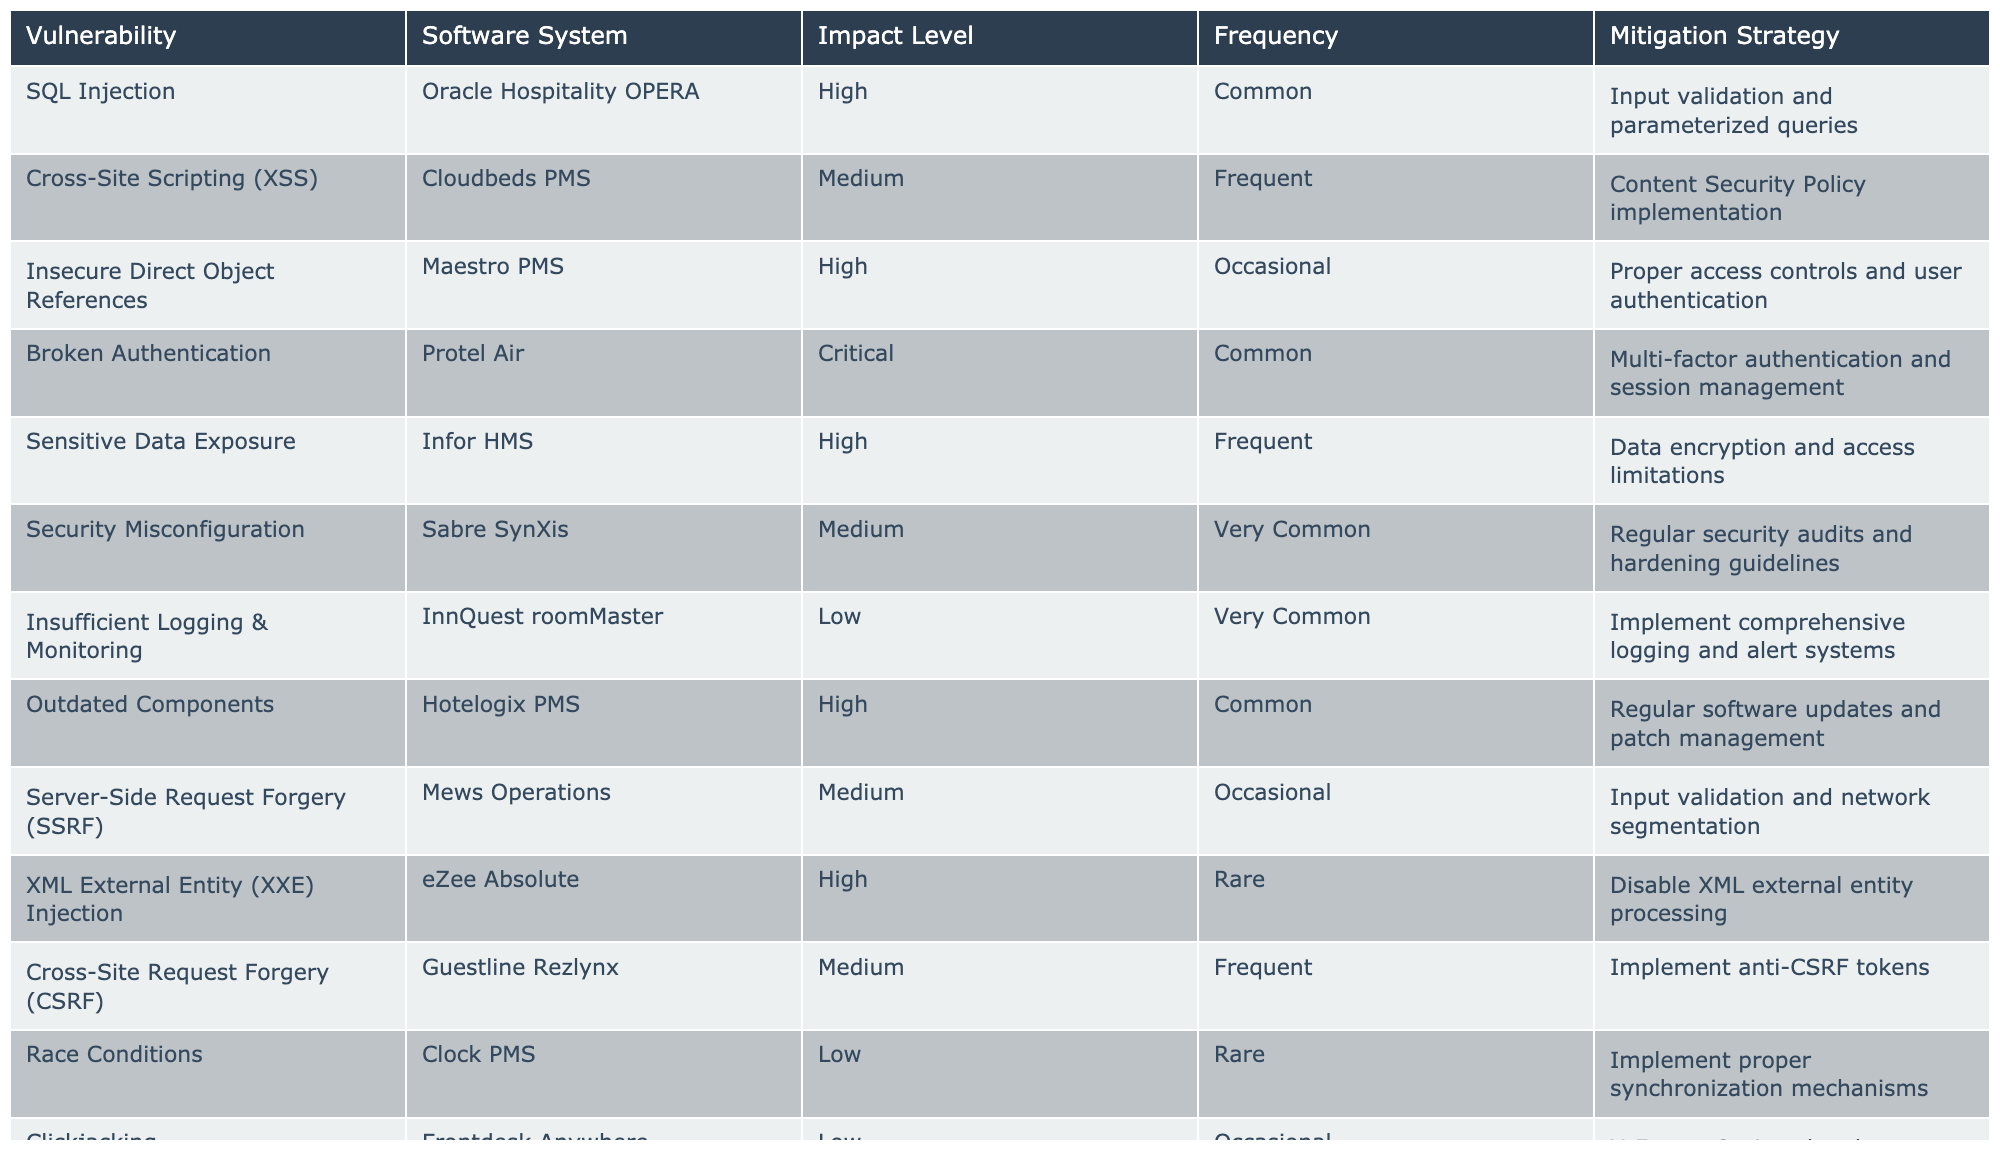What is the highest impact vulnerability listed in the table? The table shows several vulnerabilities along with their corresponding impact levels. By inspecting the impact levels, "Broken Authentication" has a "Critical" level, which is the highest.
Answer: Broken Authentication Which software system is associated with SQL Injection? The table specifies that "SQL Injection" is linked to "Oracle Hospitality OPERA."
Answer: Oracle Hospitality OPERA What mitigation strategy is suggested for Sensitive Data Exposure? The table indicates that the mitigation strategy for "Sensitive Data Exposure" is "Data encryption and access limitations."
Answer: Data encryption and access limitations How many vulnerabilities have a medium impact level? By reviewing the table, we can count the number of vulnerabilities labeled as "Medium," which includes "Cross-Site Scripting (XSS)," "Security Misconfiguration," "Server-Side Request Forgery (SSRF)," "Cross-Site Request Forgery (CSRF)." There are four medium impact vulnerabilities.
Answer: Four Is there any vulnerability that has both a high impact level and a common frequency? The table shows that "SQL Injection" and "Outdated Components" both have a high impact level and a common frequency.
Answer: Yes What is the frequency of the vulnerability "Clickjacking"? According to the table, "Clickjacking" is categorized as having an "Occasional" frequency.
Answer: Occasional What is the total number of vulnerabilities that have a critical impact level? Examining the table, we see that there are two vulnerabilities listed as "Critical," which are "Broken Authentication" and "Buffer Overflow." Thus, there are two in total.
Answer: Two Which software system listed has the highest frequency of vulnerabilities? By comparing the frequency of each software system, "Sabre SynXis" with "Security Misconfiguration" and "InnQuest roomMaster" with "Insufficient Logging & Monitoring" have a "Very Common" frequency, making them the ones with the highest frequencies.
Answer: Sabre SynXis and InnQuest roomMaster Are data encryption and access limitations recommended for any vulnerabilities? Yes, the table states that "Data encryption and access limitations" are recommended as a mitigation strategy for "Sensitive Data Exposure."
Answer: Yes What is the mitigation strategy for the vulnerability with the lowest impact level? The table indicates that "Insufficient Logging & Monitoring," which has a "Low" impact level, recommends "Implement comprehensive logging and alert systems" as its mitigation strategy.
Answer: Implement comprehensive logging and alert systems 